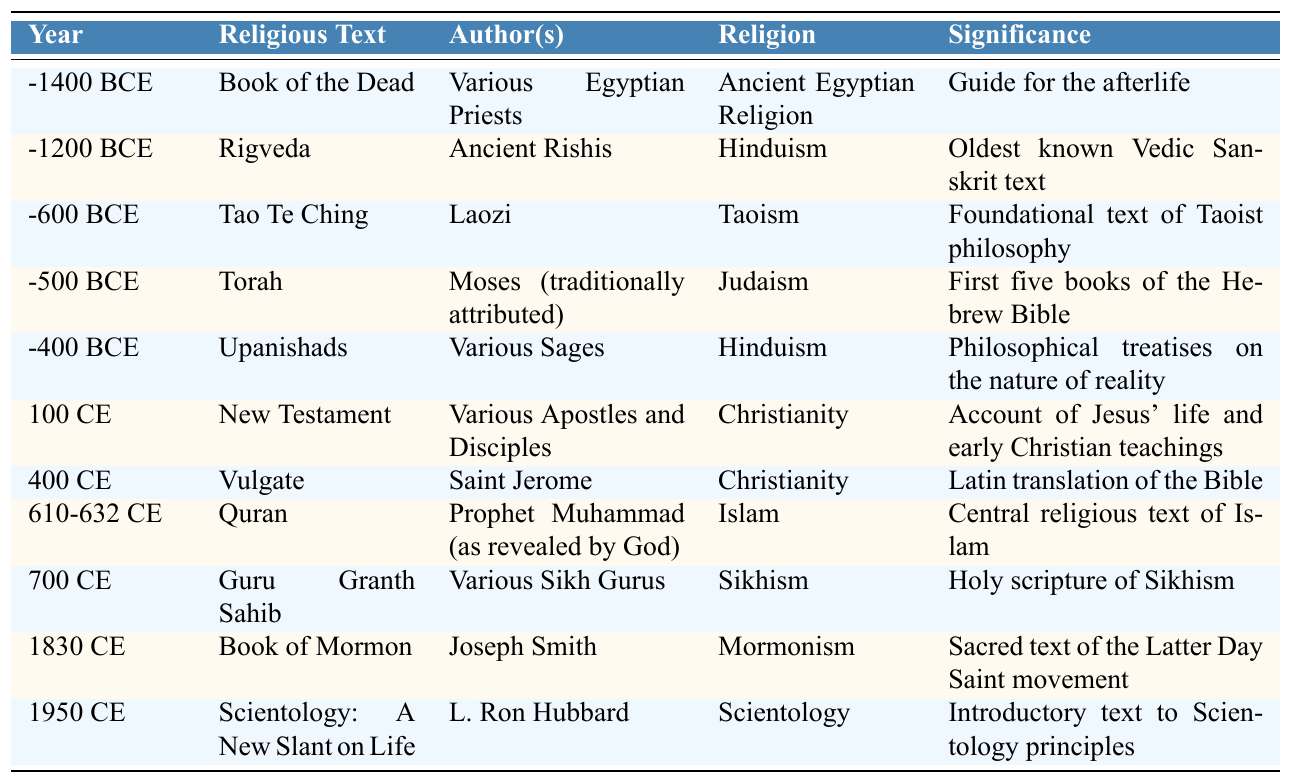What is the oldest religious text listed in the table? The table shows various religious texts along with their years of authorship. The oldest text is the "Book of the Dead" dated to -1400 BCE.
Answer: Book of the Dead Which religious text was written by Laozi? According to the table, the "Tao Te Ching" was authored by Laozi.
Answer: Tao Te Ching How many centuries apart are the Torah and the Quran? The Torah is dated around -500 BCE and the Quran is from 610-632 CE. There are 500 years from the Torah to 0 CE, plus another 632 years from 0 CE to the Quran, totaling 1132 years, which is approximately 11.32 centuries.
Answer: Approximately 11 centuries Is the "Rigveda" associated with Hinduism? The table lists the "Rigveda" under Hinduism, confirming it is indeed associated with this religion.
Answer: Yes Which religious text is the most recent according to the table? The most recent text listed is "Scientology: A New Slant on Life," which was published in 1950 CE.
Answer: Scientology: A New Slant on Life List all the texts associated with Christianity in the table. The texts associated with Christianity in the table are the "New Testament" and the "Vulgate."
Answer: New Testament, Vulgate What common theme do the "Upanishads" and the "Tao Te Ching" share? The "Upanishads" and the "Tao Te Ching" share a philosophical theme, as they both explore the nature of reality and existence.
Answer: Philosophical exploration Which texts were revealed according to their descriptions? The "Quran" is described as being revealed to Prophet Muhammad, indicating it is considered a revelation.
Answer: Quran How many religious texts were authored by various individuals or sages? The table includes three texts authored by various sages: the "Rigveda," "Upanishads," and "Guru Granth Sahib."
Answer: Three texts Determine the time span between the earliest and latest texts in the table. The earliest text is from -1400 BCE and the latest from 1950 CE. The time span is 1400 years BCE plus 1950 years CE, totaling 3350 years.
Answer: 3350 years 